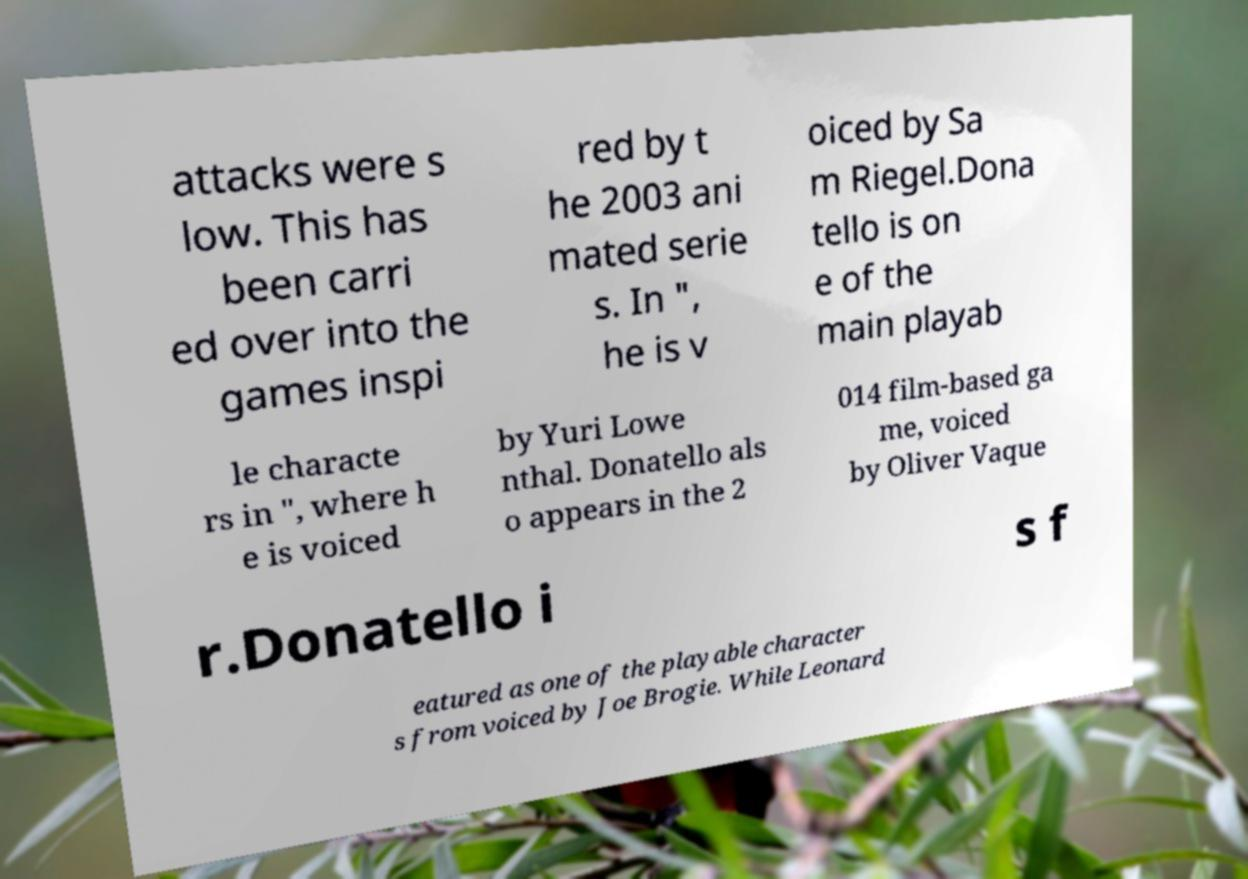Please read and relay the text visible in this image. What does it say? attacks were s low. This has been carri ed over into the games inspi red by t he 2003 ani mated serie s. In ", he is v oiced by Sa m Riegel.Dona tello is on e of the main playab le characte rs in ", where h e is voiced by Yuri Lowe nthal. Donatello als o appears in the 2 014 film-based ga me, voiced by Oliver Vaque r.Donatello i s f eatured as one of the playable character s from voiced by Joe Brogie. While Leonard 